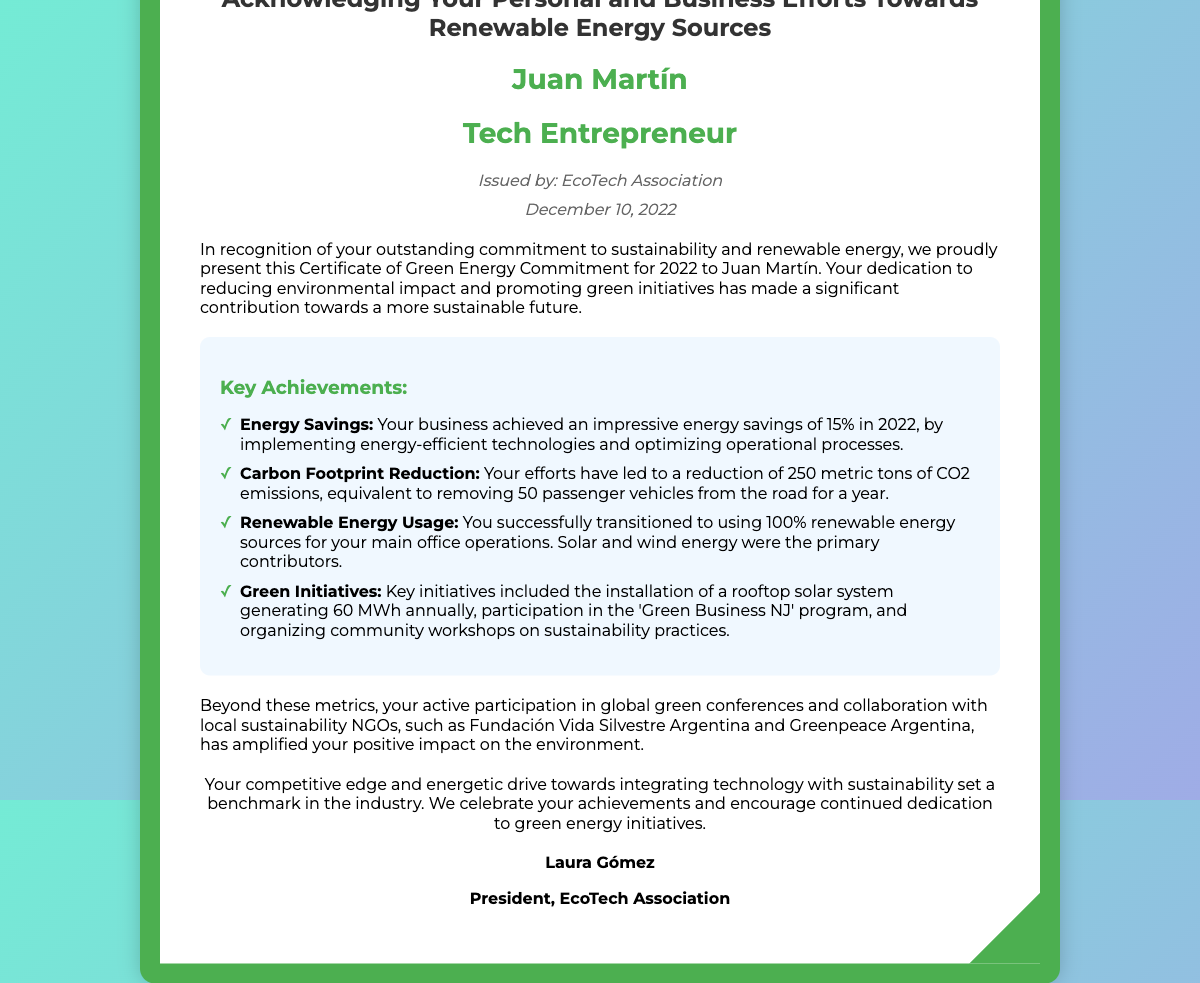What is the name of the recipient? The recipient is mentioned at the top of the document as Juan Martín.
Answer: Juan Martín What organization issued the certificate? The issuer is clearly stated in the document as EcoTech Association.
Answer: EcoTech Association When was the certificate issued? The date of issuance is provided in the document as December 10, 2022.
Answer: December 10, 2022 How much was the energy savings achieved? The document states an energy savings of 15%.
Answer: 15% What is the reduction in carbon footprint? The document indicates a reduction of 250 metric tons of CO2 emissions.
Answer: 250 metric tons What type of energy sources does the business use? The document highlights a transition to using 100% renewable energy sources.
Answer: 100% renewable energy sources What was a key initiative mentioned in the document? One of the initiatives listed is the installation of a rooftop solar system generating 60 MWh annually.
Answer: Rooftop solar system generating 60 MWh annually Who is the signer of the certificate? The document lists the signer as Laura Gómez.
Answer: Laura Gómez What is mentioned as a benefit of the recipient's efforts? The document states that these efforts amplified the positive impact on the environment.
Answer: Amplified positive impact on the environment 